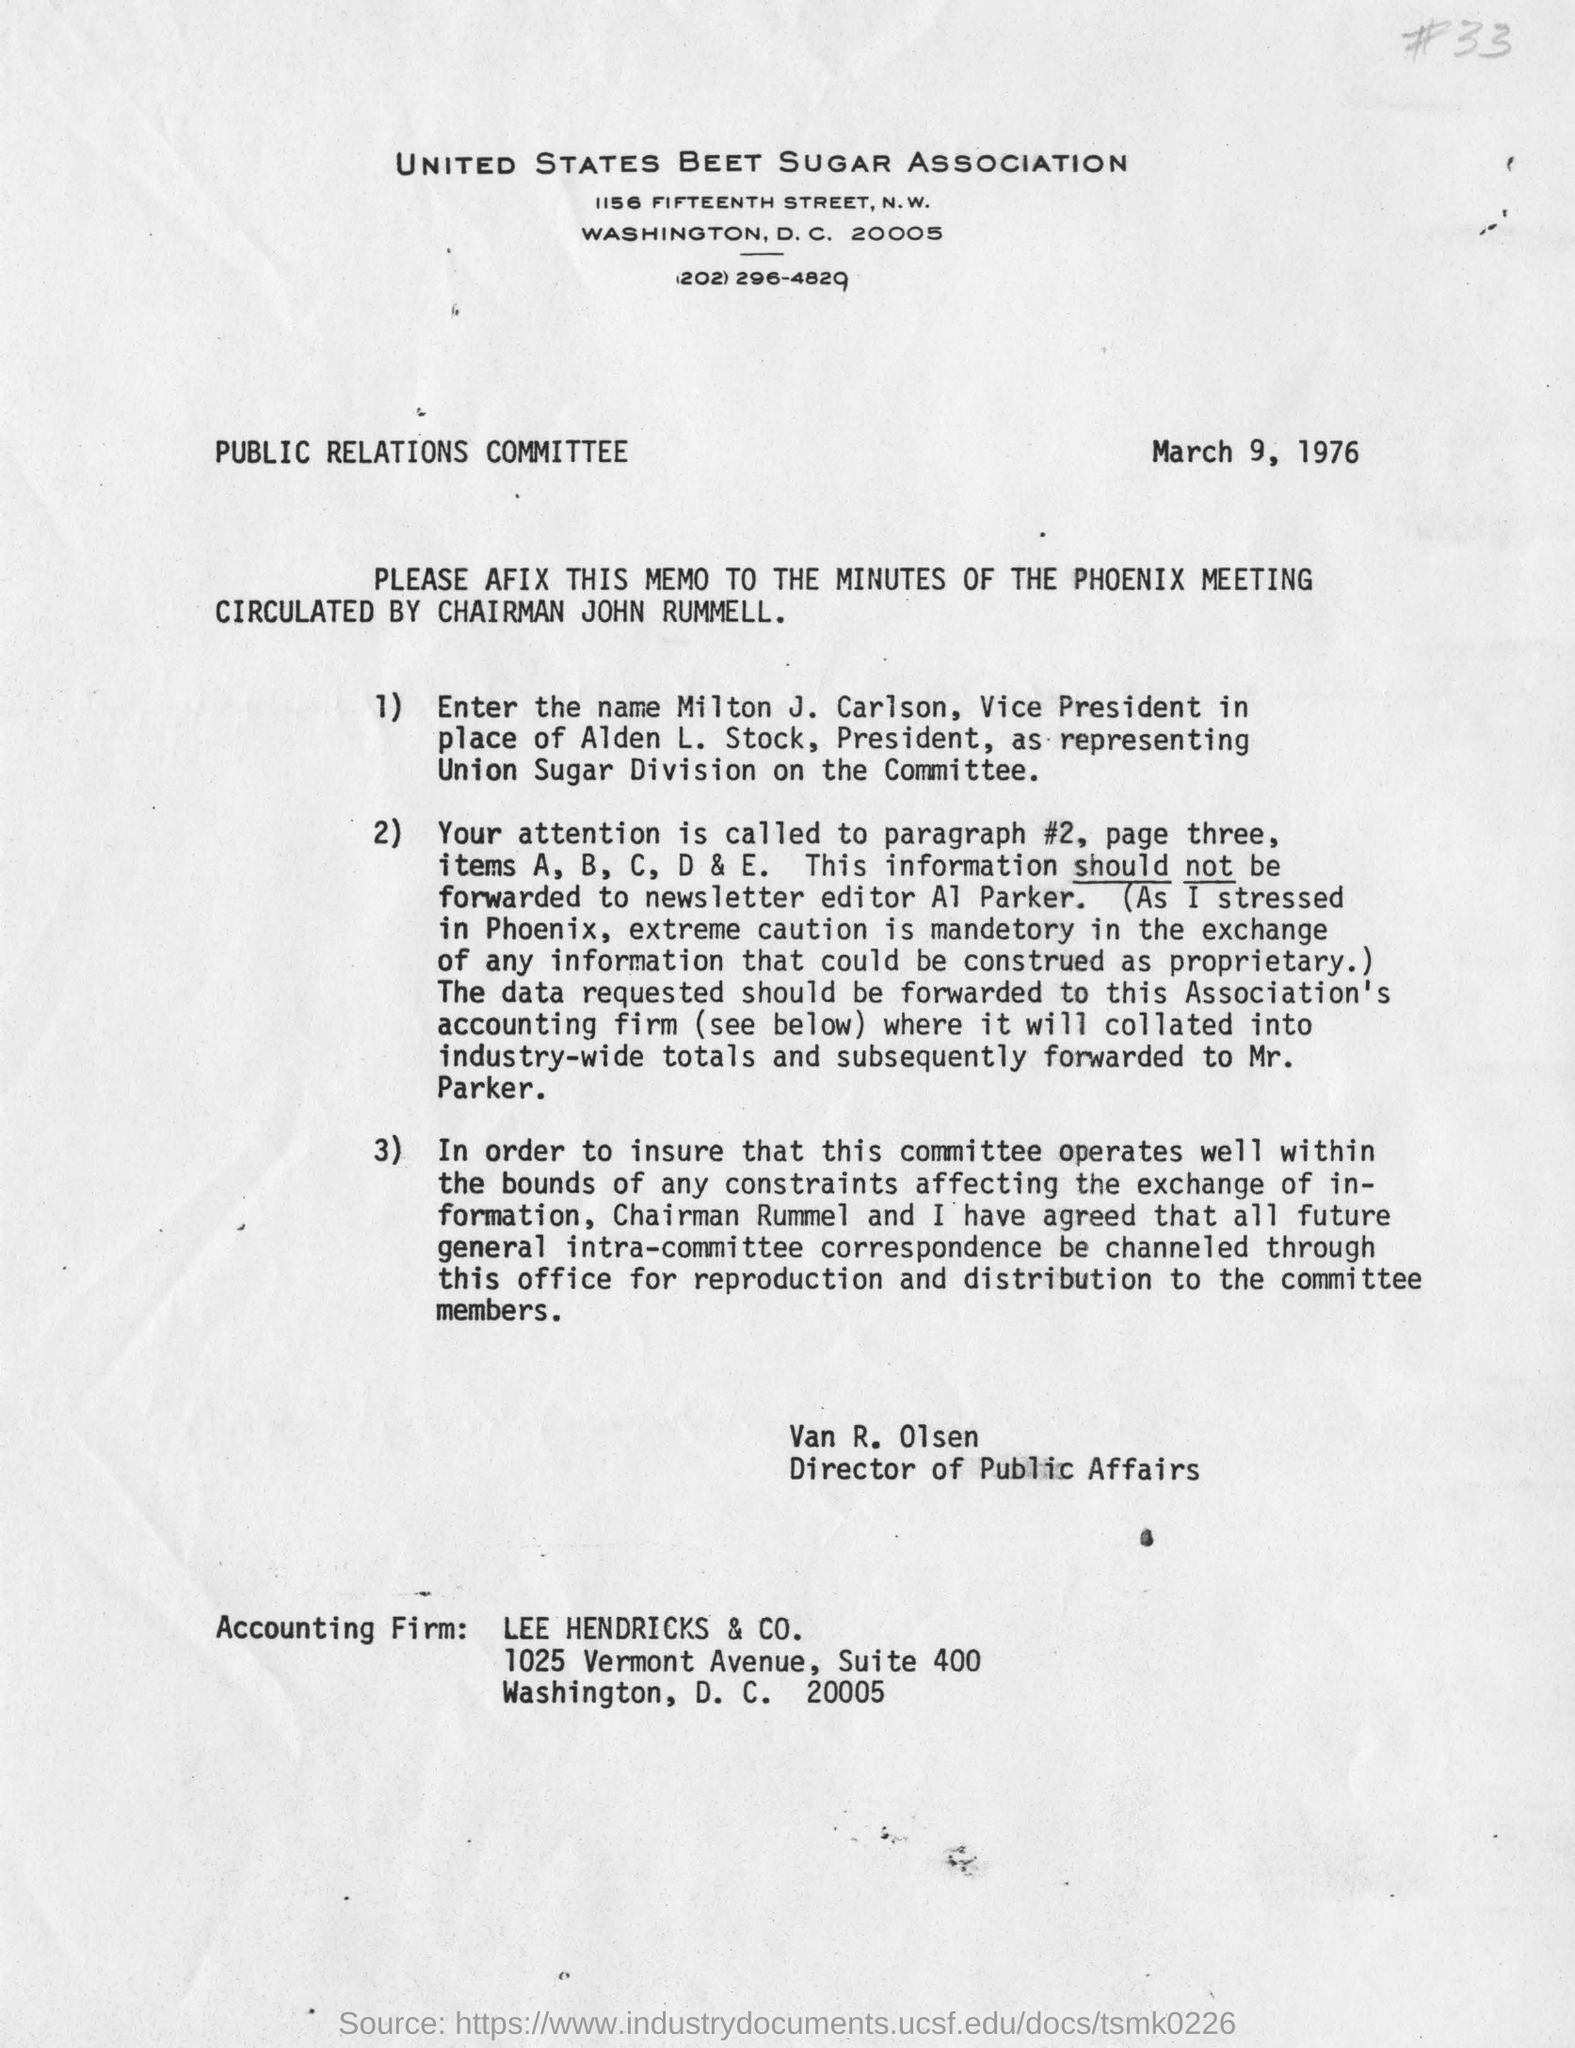Specify some key components in this picture. LEE HENDRICKS & CO. is the accounting firm. March 9, 1976 is the date of the letter. Milton J. Carlson is the vice president in the place of Alden L. Stock, who is the president. The United States Beet Sugar Association is the name of the sugar association in the United States. Van R. Olsen is the director of public affairs. 